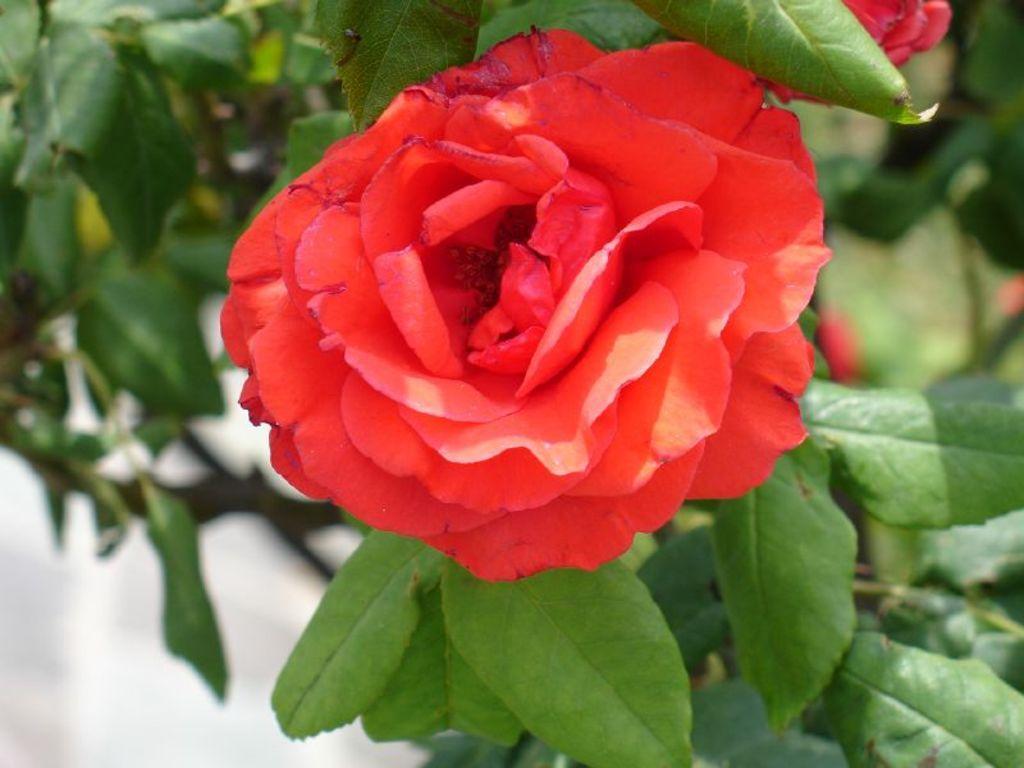Could you give a brief overview of what you see in this image? In this picture we can see few flowers and leaves. 